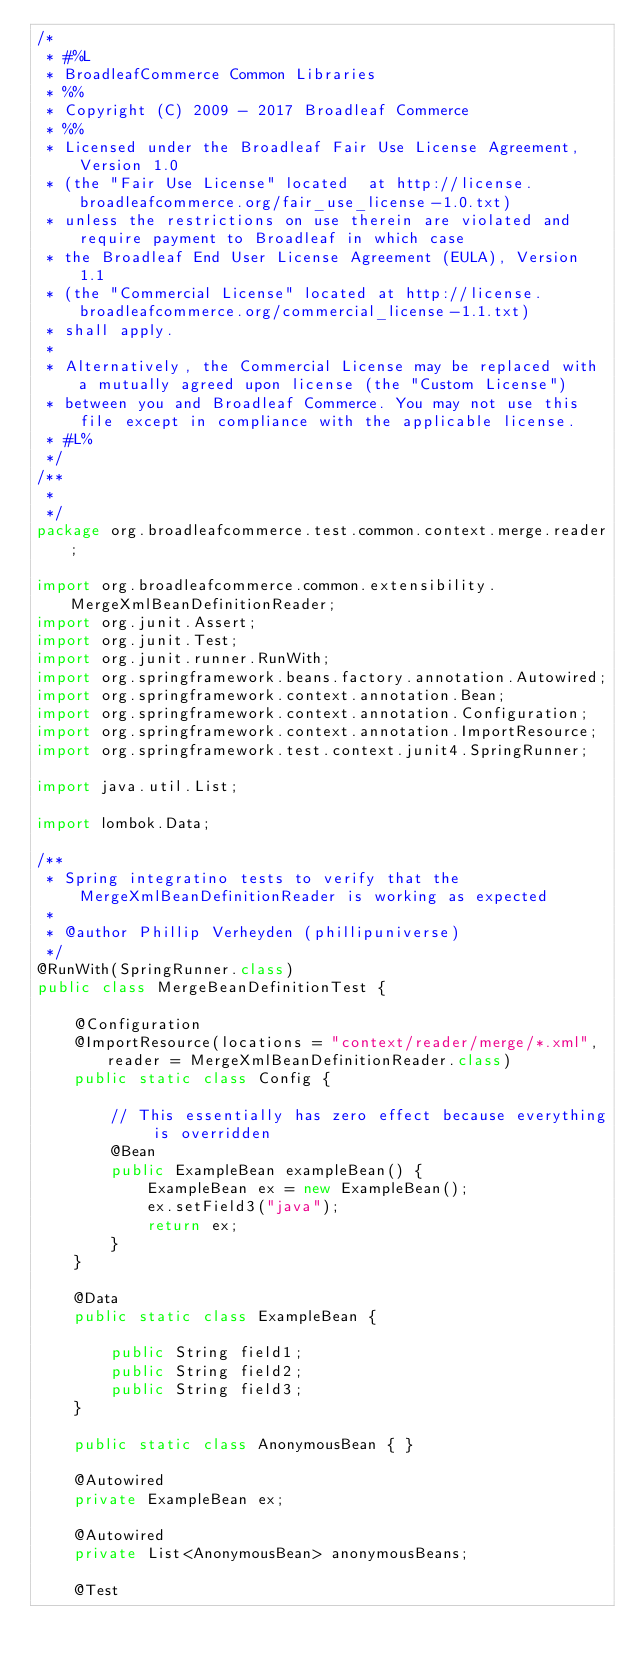Convert code to text. <code><loc_0><loc_0><loc_500><loc_500><_Java_>/*
 * #%L
 * BroadleafCommerce Common Libraries
 * %%
 * Copyright (C) 2009 - 2017 Broadleaf Commerce
 * %%
 * Licensed under the Broadleaf Fair Use License Agreement, Version 1.0
 * (the "Fair Use License" located  at http://license.broadleafcommerce.org/fair_use_license-1.0.txt)
 * unless the restrictions on use therein are violated and require payment to Broadleaf in which case
 * the Broadleaf End User License Agreement (EULA), Version 1.1
 * (the "Commercial License" located at http://license.broadleafcommerce.org/commercial_license-1.1.txt)
 * shall apply.
 * 
 * Alternatively, the Commercial License may be replaced with a mutually agreed upon license (the "Custom License")
 * between you and Broadleaf Commerce. You may not use this file except in compliance with the applicable license.
 * #L%
 */
/**
 * 
 */
package org.broadleafcommerce.test.common.context.merge.reader;

import org.broadleafcommerce.common.extensibility.MergeXmlBeanDefinitionReader;
import org.junit.Assert;
import org.junit.Test;
import org.junit.runner.RunWith;
import org.springframework.beans.factory.annotation.Autowired;
import org.springframework.context.annotation.Bean;
import org.springframework.context.annotation.Configuration;
import org.springframework.context.annotation.ImportResource;
import org.springframework.test.context.junit4.SpringRunner;

import java.util.List;

import lombok.Data;

/**
 * Spring integratino tests to verify that the MergeXmlBeanDefinitionReader is working as expected
 * 
 * @author Phillip Verheyden (phillipuniverse)
 */
@RunWith(SpringRunner.class)
public class MergeBeanDefinitionTest {

    @Configuration
    @ImportResource(locations = "context/reader/merge/*.xml", reader = MergeXmlBeanDefinitionReader.class)
    public static class Config {
        
        // This essentially has zero effect because everything is overridden
        @Bean
        public ExampleBean exampleBean() {
            ExampleBean ex = new ExampleBean();
            ex.setField3("java");
            return ex;
        }
    }
    
    @Data
    public static class ExampleBean {

        public String field1;
        public String field2;
        public String field3;
    }
    
    public static class AnonymousBean { }
    
    @Autowired
    private ExampleBean ex;
    
    @Autowired
    private List<AnonymousBean> anonymousBeans;
    
    @Test</code> 